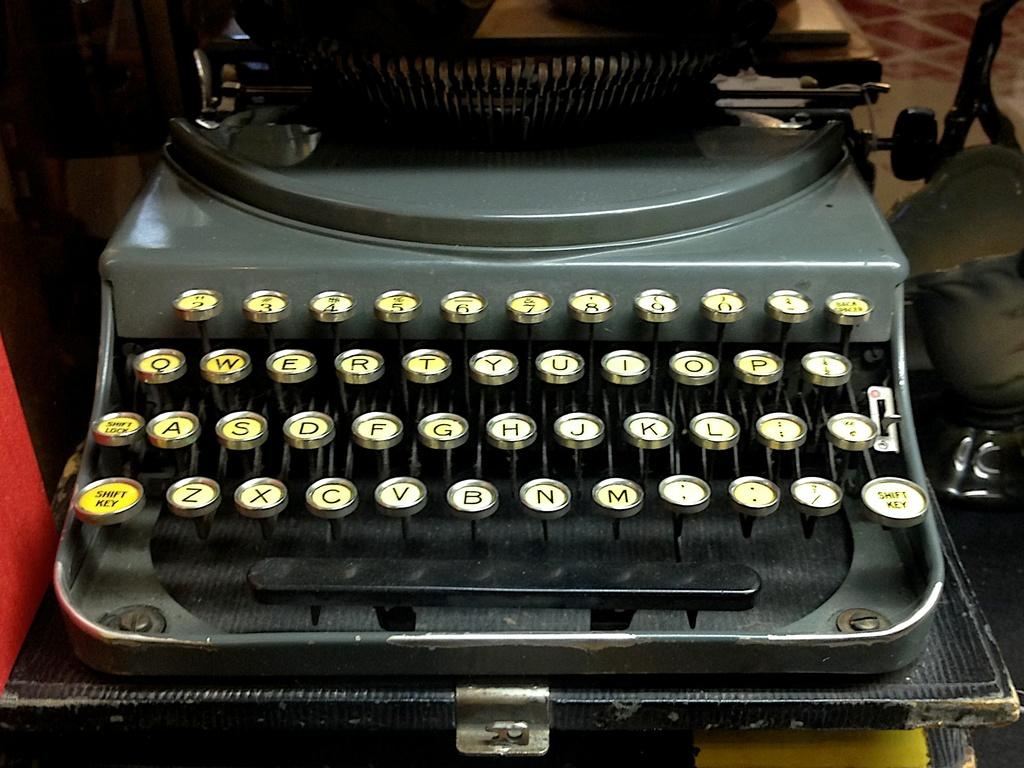<image>
Give a short and clear explanation of the subsequent image. Black typewriter on display with the G key between the F and H key. 